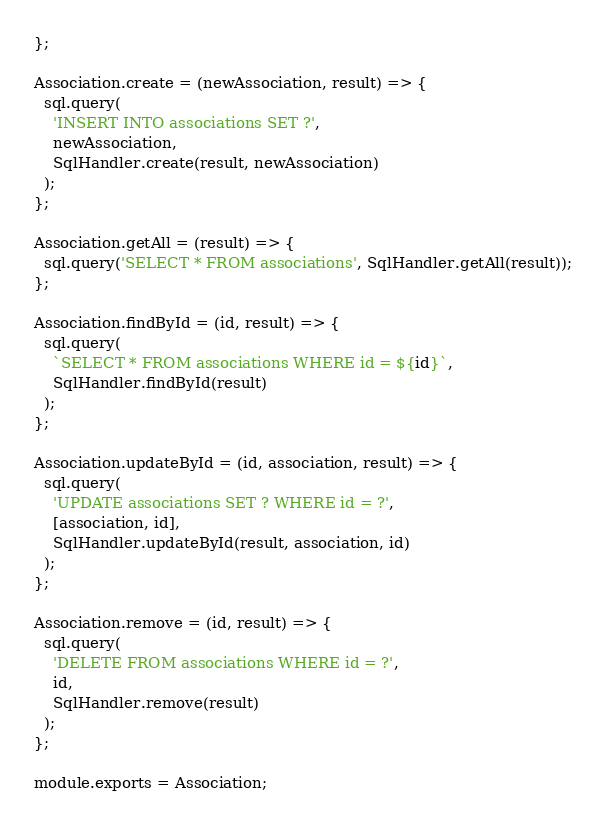<code> <loc_0><loc_0><loc_500><loc_500><_JavaScript_>};

Association.create = (newAssociation, result) => {
  sql.query(
    'INSERT INTO associations SET ?',
    newAssociation,
    SqlHandler.create(result, newAssociation)
  );
};

Association.getAll = (result) => {
  sql.query('SELECT * FROM associations', SqlHandler.getAll(result));
};

Association.findById = (id, result) => {
  sql.query(
    `SELECT * FROM associations WHERE id = ${id}`,
    SqlHandler.findById(result)
  );
};

Association.updateById = (id, association, result) => {
  sql.query(
    'UPDATE associations SET ? WHERE id = ?',
    [association, id],
    SqlHandler.updateById(result, association, id)
  );
};

Association.remove = (id, result) => {
  sql.query(
    'DELETE FROM associations WHERE id = ?',
    id,
    SqlHandler.remove(result)
  );
};

module.exports = Association;
</code> 